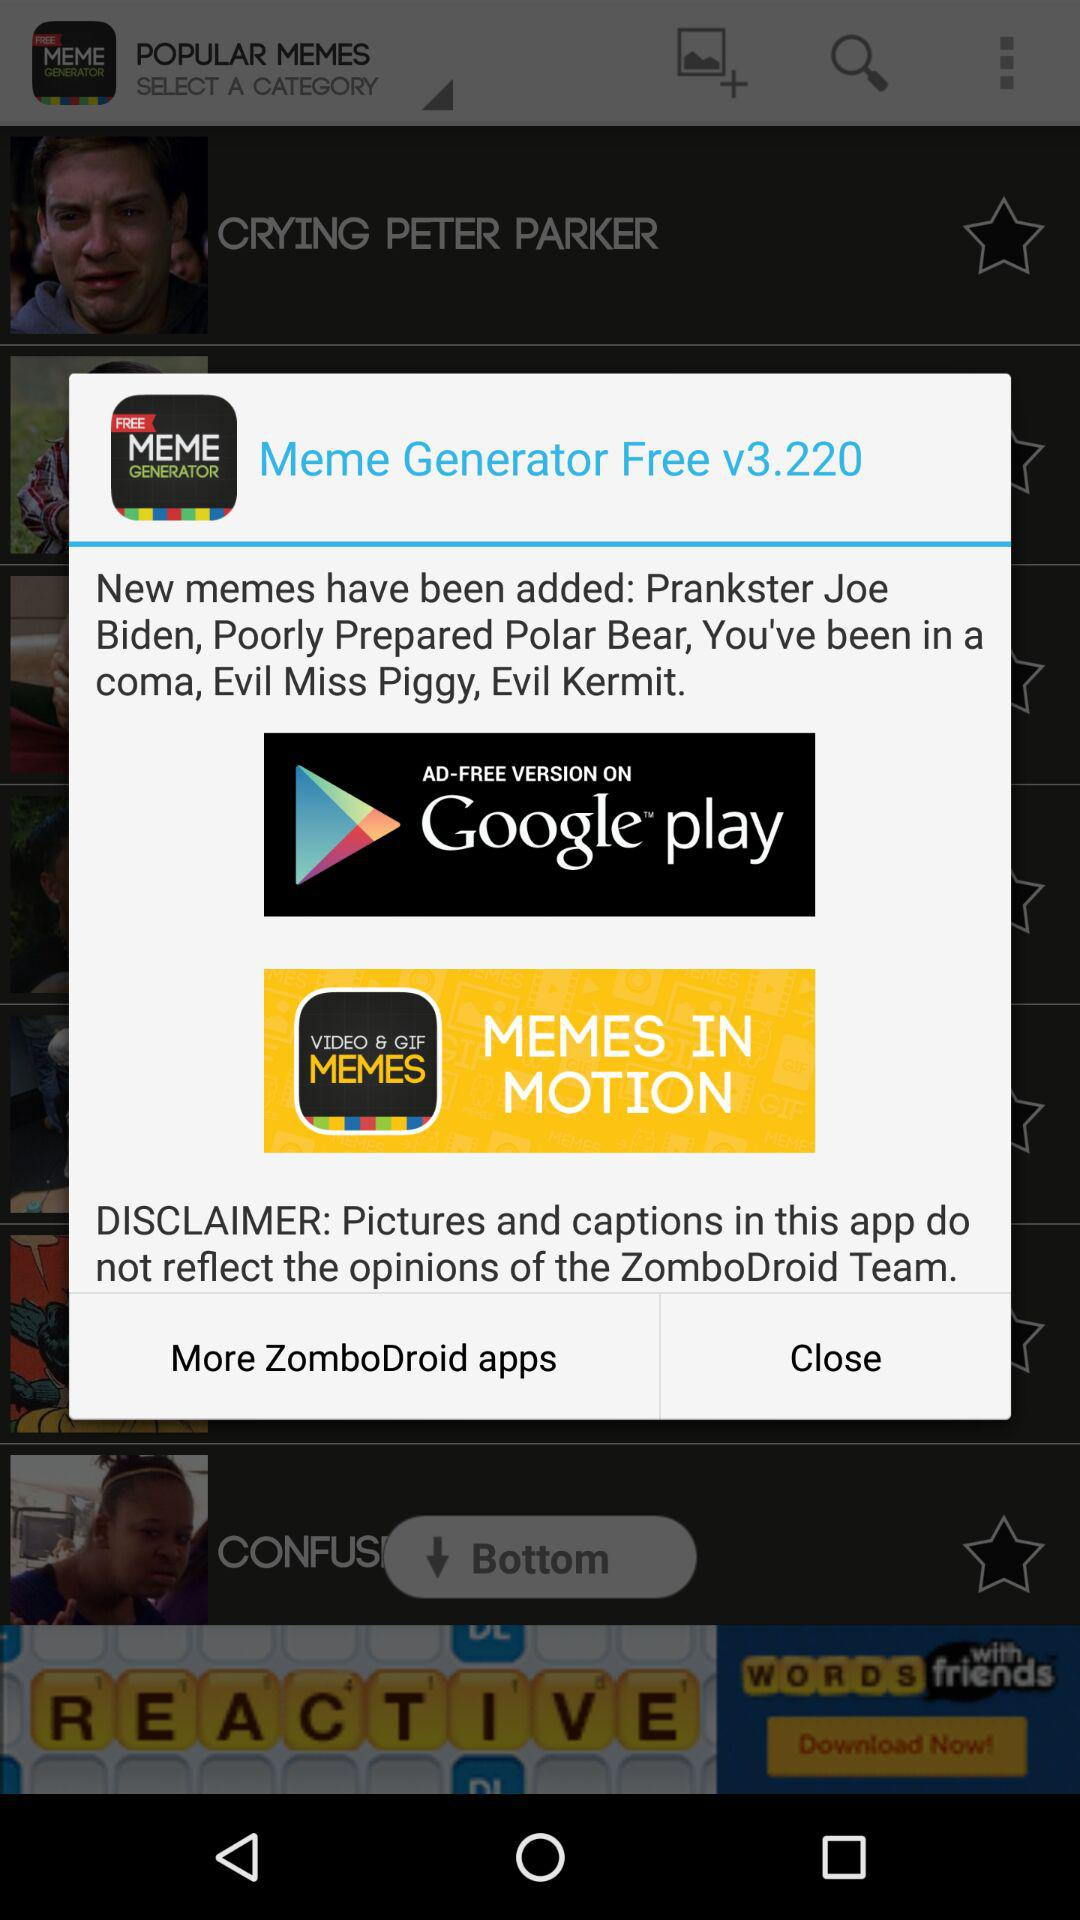What is the version of the "Meme Generator Free" application? The version is v3.220. 